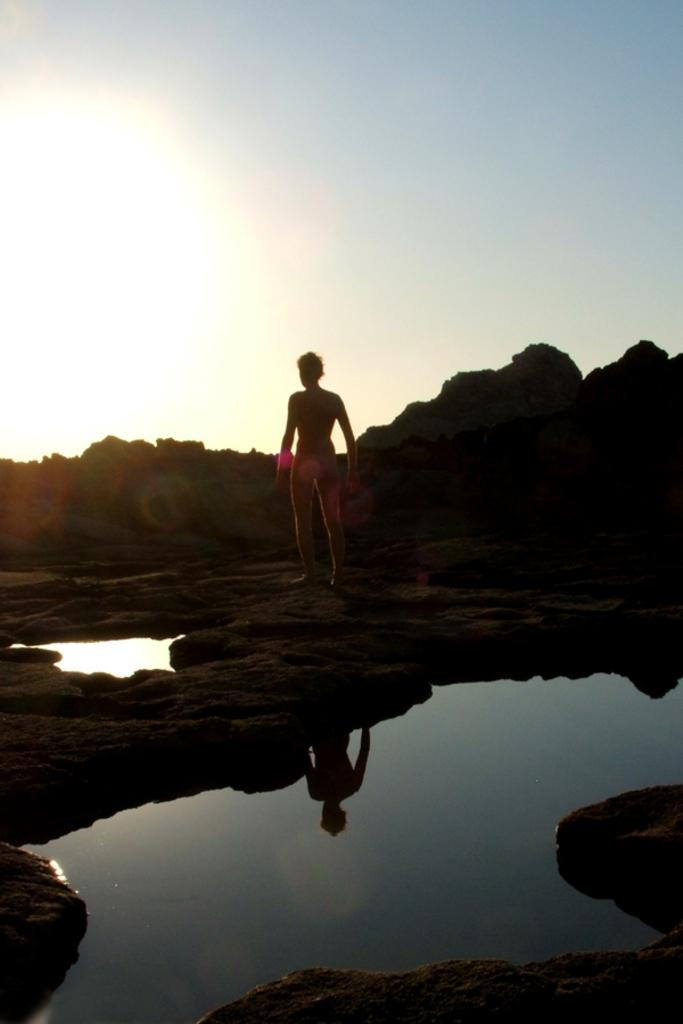What is the person in the image doing? The person is standing on a path in the image. What can be seen in the background of the image? There is some water visible in the image. What is the source of light on the left side of the image? Sun rays are visible on the left side of the image. Where is the dock located in the image? There is no dock present in the image. What type of ball is being used by the person in the image? There is no ball present in the image. 